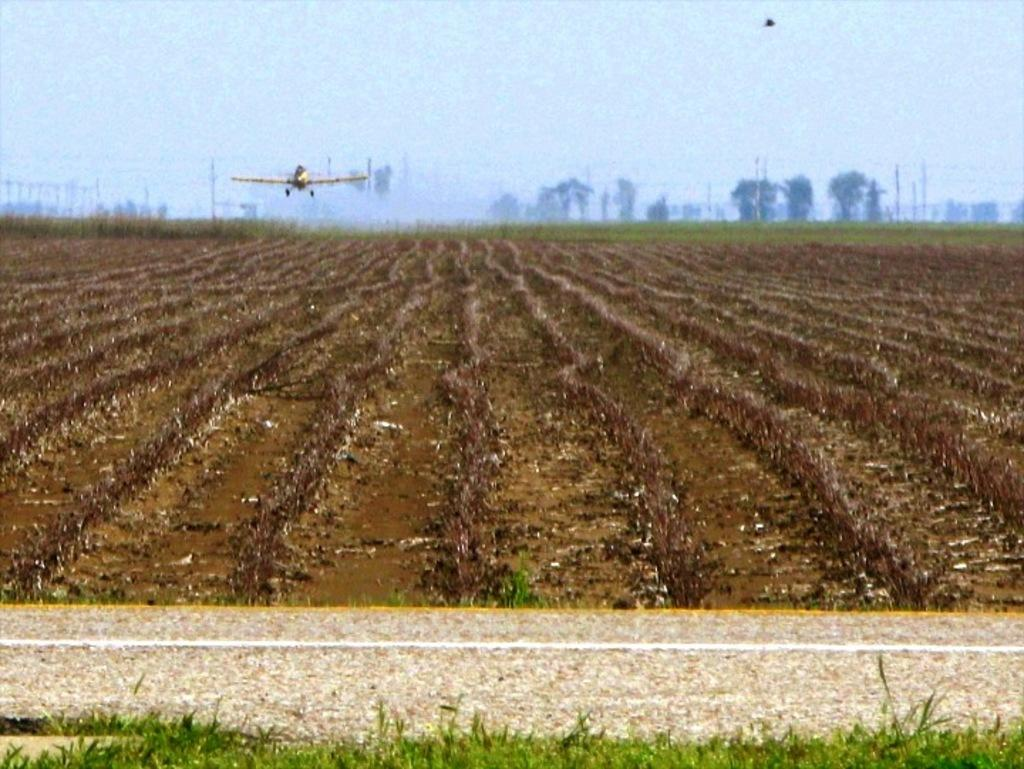What is visible on the ground in the image? The ground is visible in the image, and there is grass on the ground. What is flying in the air in the image? An aircraft is flying in the air in the image. What can be seen in the background of the image? There are trees, poles, and the sky visible in the background of the image. How many squares can be seen on the desk in the image? There is no desk present in the image, so it is not possible to determine the number of squares. What type of cent is visible in the image? There is no cent present in the image. 